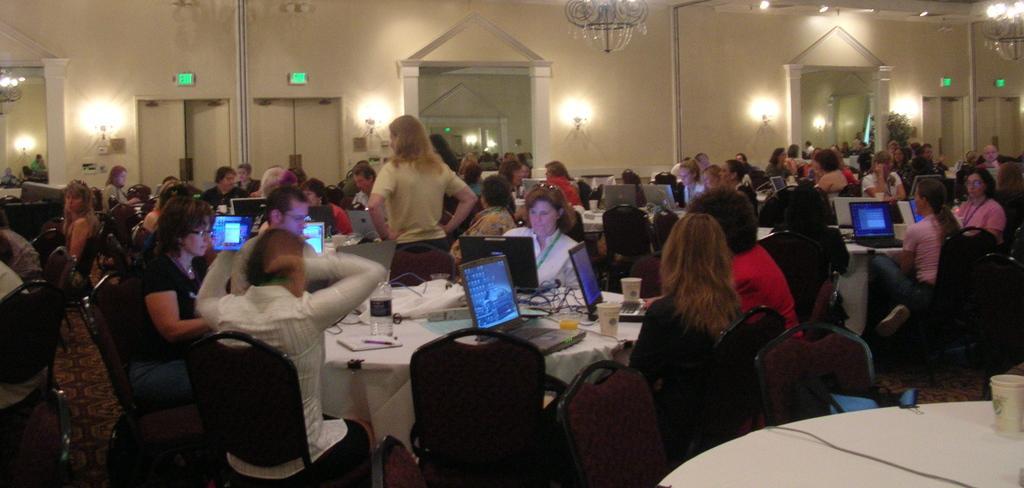How would you summarize this image in a sentence or two? There are group of people sitting in chairs and there is a table in front of them which has laptops on it and there is a person standing in the center. 